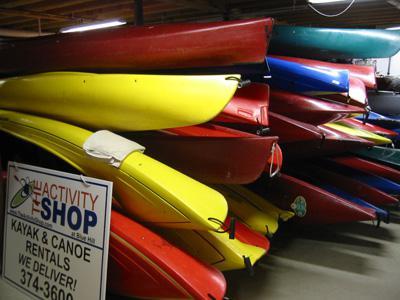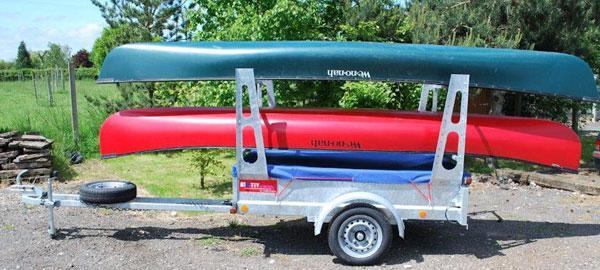The first image is the image on the left, the second image is the image on the right. Given the left and right images, does the statement "There is a green canoe above a red canoe in the right image." hold true? Answer yes or no. Yes. The first image is the image on the left, the second image is the image on the right. For the images shown, is this caption "At least one canoe is loaded onto a wooden trailer with a black cover in the image on the left." true? Answer yes or no. No. 